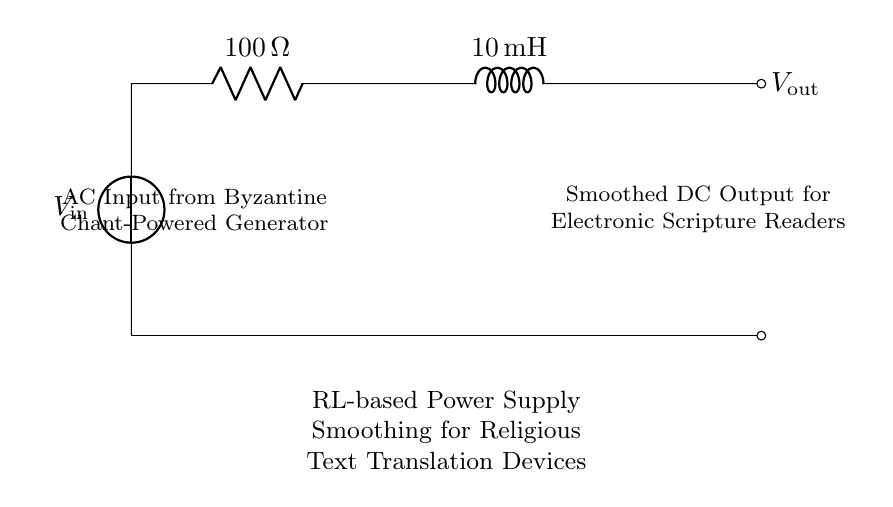What is the resistance value in this circuit? The resistance value is indicated next to the resistor in the diagram. It shows as one hundred ohms.
Answer: one hundred ohms What is the inductance value in this circuit? The inductance value is displayed next to the inductor in the diagram, which is ten milli-henries.
Answer: ten milli-henries What type of power supply is used in this circuit? The circuit diagram labels the voltage source as an AC input, specifically from a Byzantine chant-powered generator.
Answer: AC input What is the function of the RL combination in this circuit? The RL combination serves to smooth the output voltage by filtering fluctuations in the AC input, providing a steadier DC output for downstream components.
Answer: voltage smoothing How does the output voltage relate to the input voltage in this circuit? The output voltage is derived from the input voltage after it passes through the resistor and inductor, where it gets smoothed. The exact value of Vout is not specified; it will depend on the input and the load.
Answer: smoothed voltage What is the purpose of the smoothing in religious text translation devices? Smoothing the power supply ensures that the devices, such as electronic scripture readers, operate without interruptions or fluctuations that may disrupt their function.
Answer: uninterrupted operation 